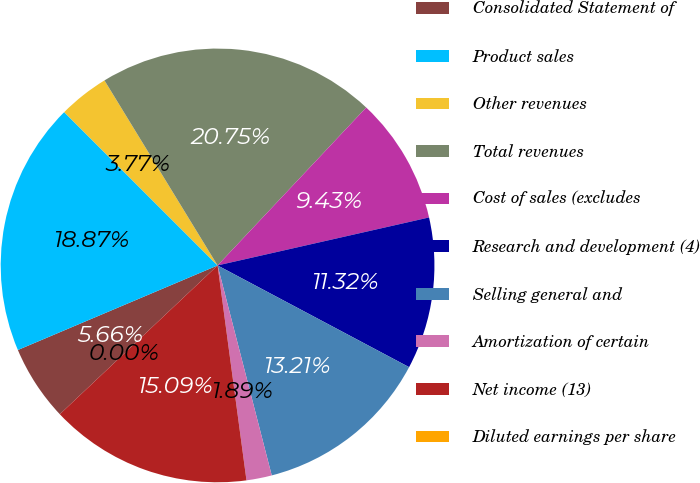<chart> <loc_0><loc_0><loc_500><loc_500><pie_chart><fcel>Consolidated Statement of<fcel>Product sales<fcel>Other revenues<fcel>Total revenues<fcel>Cost of sales (excludes<fcel>Research and development (4)<fcel>Selling general and<fcel>Amortization of certain<fcel>Net income (13)<fcel>Diluted earnings per share<nl><fcel>5.66%<fcel>18.87%<fcel>3.77%<fcel>20.75%<fcel>9.43%<fcel>11.32%<fcel>13.21%<fcel>1.89%<fcel>15.09%<fcel>0.0%<nl></chart> 